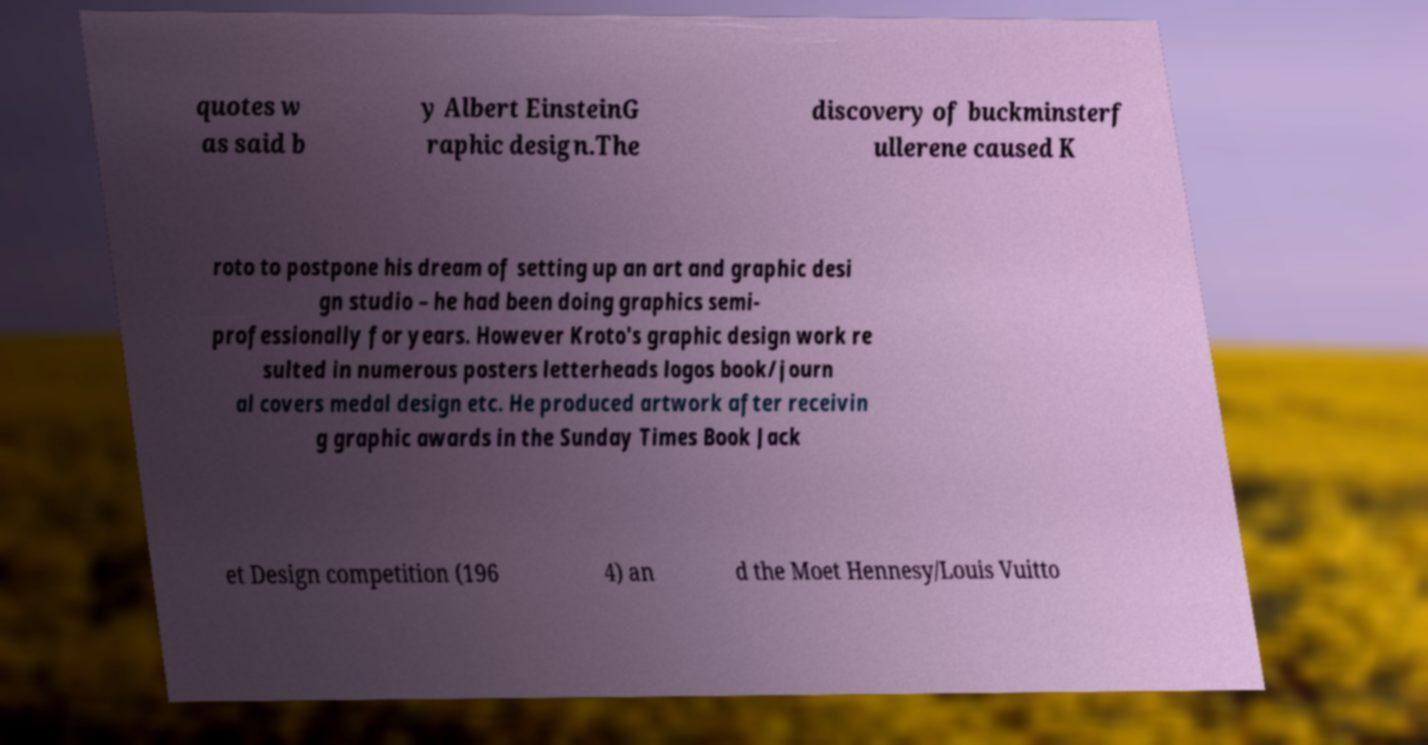What messages or text are displayed in this image? I need them in a readable, typed format. quotes w as said b y Albert EinsteinG raphic design.The discovery of buckminsterf ullerene caused K roto to postpone his dream of setting up an art and graphic desi gn studio – he had been doing graphics semi- professionally for years. However Kroto's graphic design work re sulted in numerous posters letterheads logos book/journ al covers medal design etc. He produced artwork after receivin g graphic awards in the Sunday Times Book Jack et Design competition (196 4) an d the Moet Hennesy/Louis Vuitto 